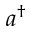Convert formula to latex. <formula><loc_0><loc_0><loc_500><loc_500>a ^ { \dag }</formula> 